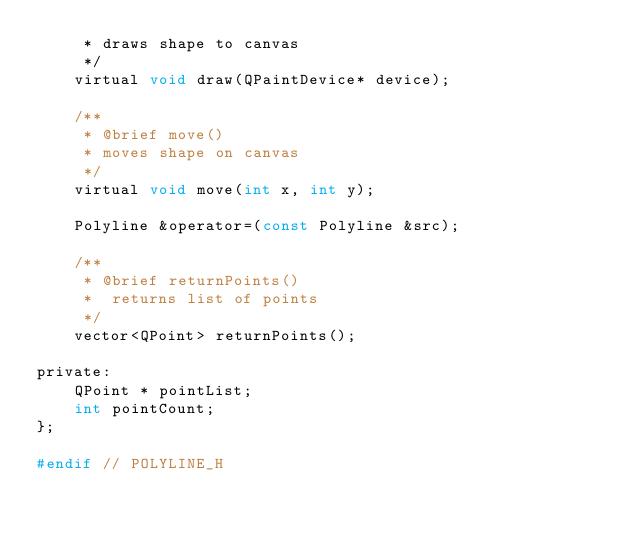<code> <loc_0><loc_0><loc_500><loc_500><_C_>     * draws shape to canvas
     */
    virtual void draw(QPaintDevice* device);

    /**
     * @brief move()
     * moves shape on canvas
     */
    virtual void move(int x, int y);

    Polyline &operator=(const Polyline &src);

    /**
     * @brief returnPoints()
     *  returns list of points
     */
    vector<QPoint> returnPoints();

private:
    QPoint * pointList;
    int pointCount;
};

#endif // POLYLINE_H
</code> 